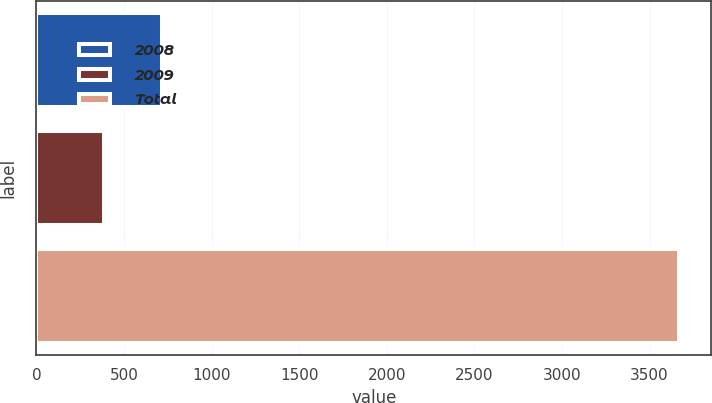Convert chart to OTSL. <chart><loc_0><loc_0><loc_500><loc_500><bar_chart><fcel>2008<fcel>2009<fcel>Total<nl><fcel>714.3<fcel>386<fcel>3669<nl></chart> 